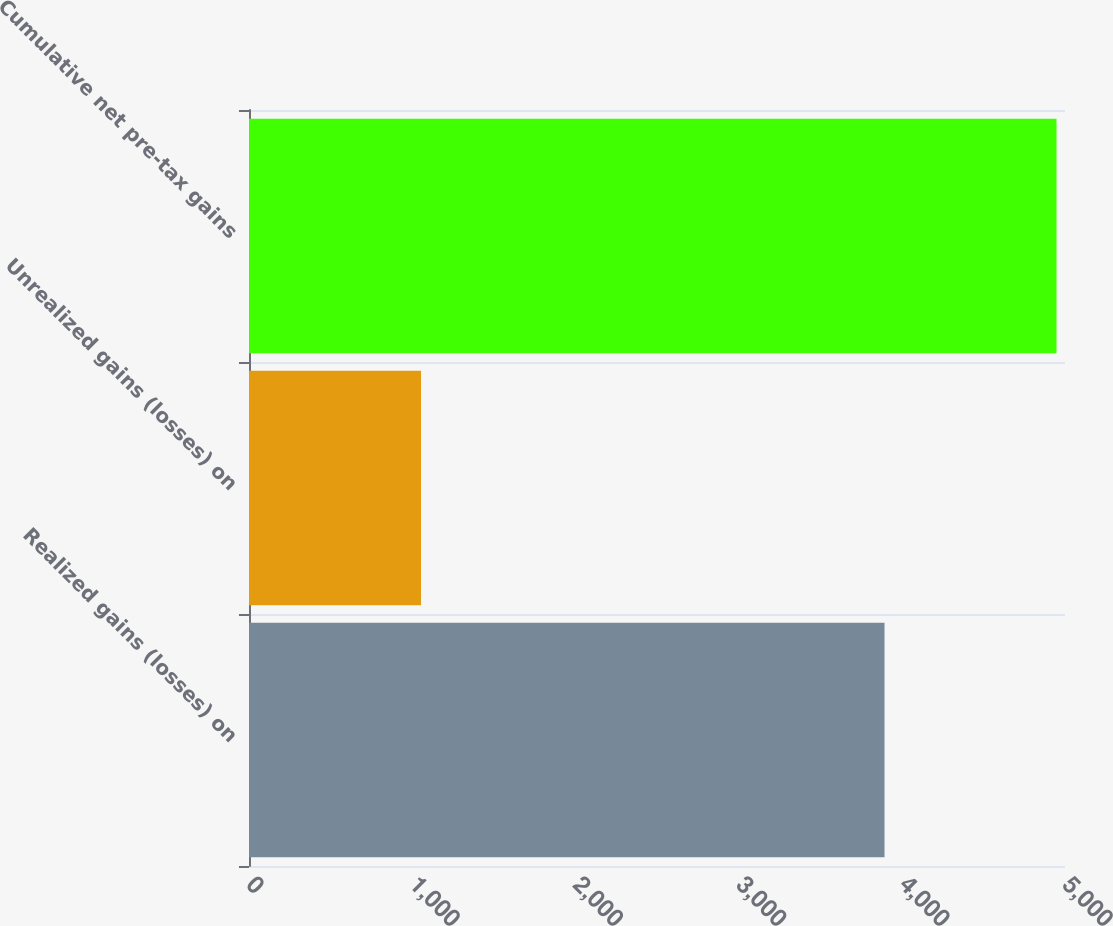Convert chart to OTSL. <chart><loc_0><loc_0><loc_500><loc_500><bar_chart><fcel>Realized gains (losses) on<fcel>Unrealized gains (losses) on<fcel>Cumulative net pre-tax gains<nl><fcel>3894<fcel>1054<fcel>4948<nl></chart> 